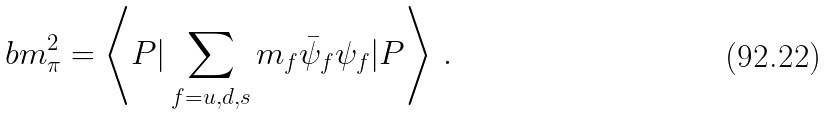Convert formula to latex. <formula><loc_0><loc_0><loc_500><loc_500>b m _ { \pi } ^ { 2 } = \left \langle P | \sum _ { f = u , d , s } m _ { f } \bar { \psi } _ { f } \psi _ { f } | P \right \rangle \, .</formula> 